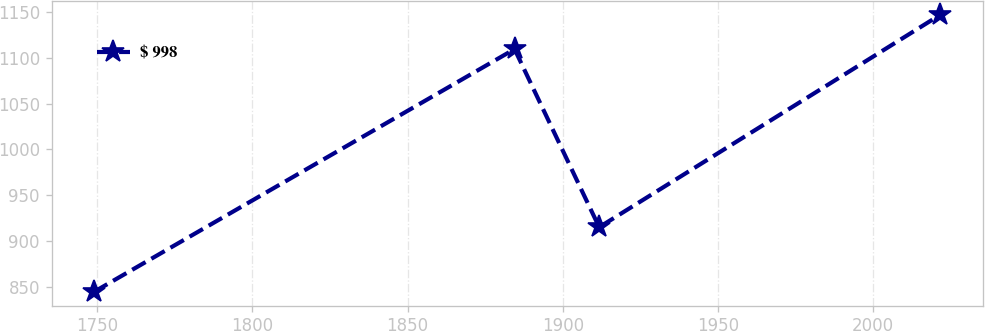Convert chart. <chart><loc_0><loc_0><loc_500><loc_500><line_chart><ecel><fcel>$ 998<nl><fcel>1748.94<fcel>844.8<nl><fcel>1884.48<fcel>1109.39<nl><fcel>1911.75<fcel>915.29<nl><fcel>2021.67<fcel>1146.81<nl></chart> 